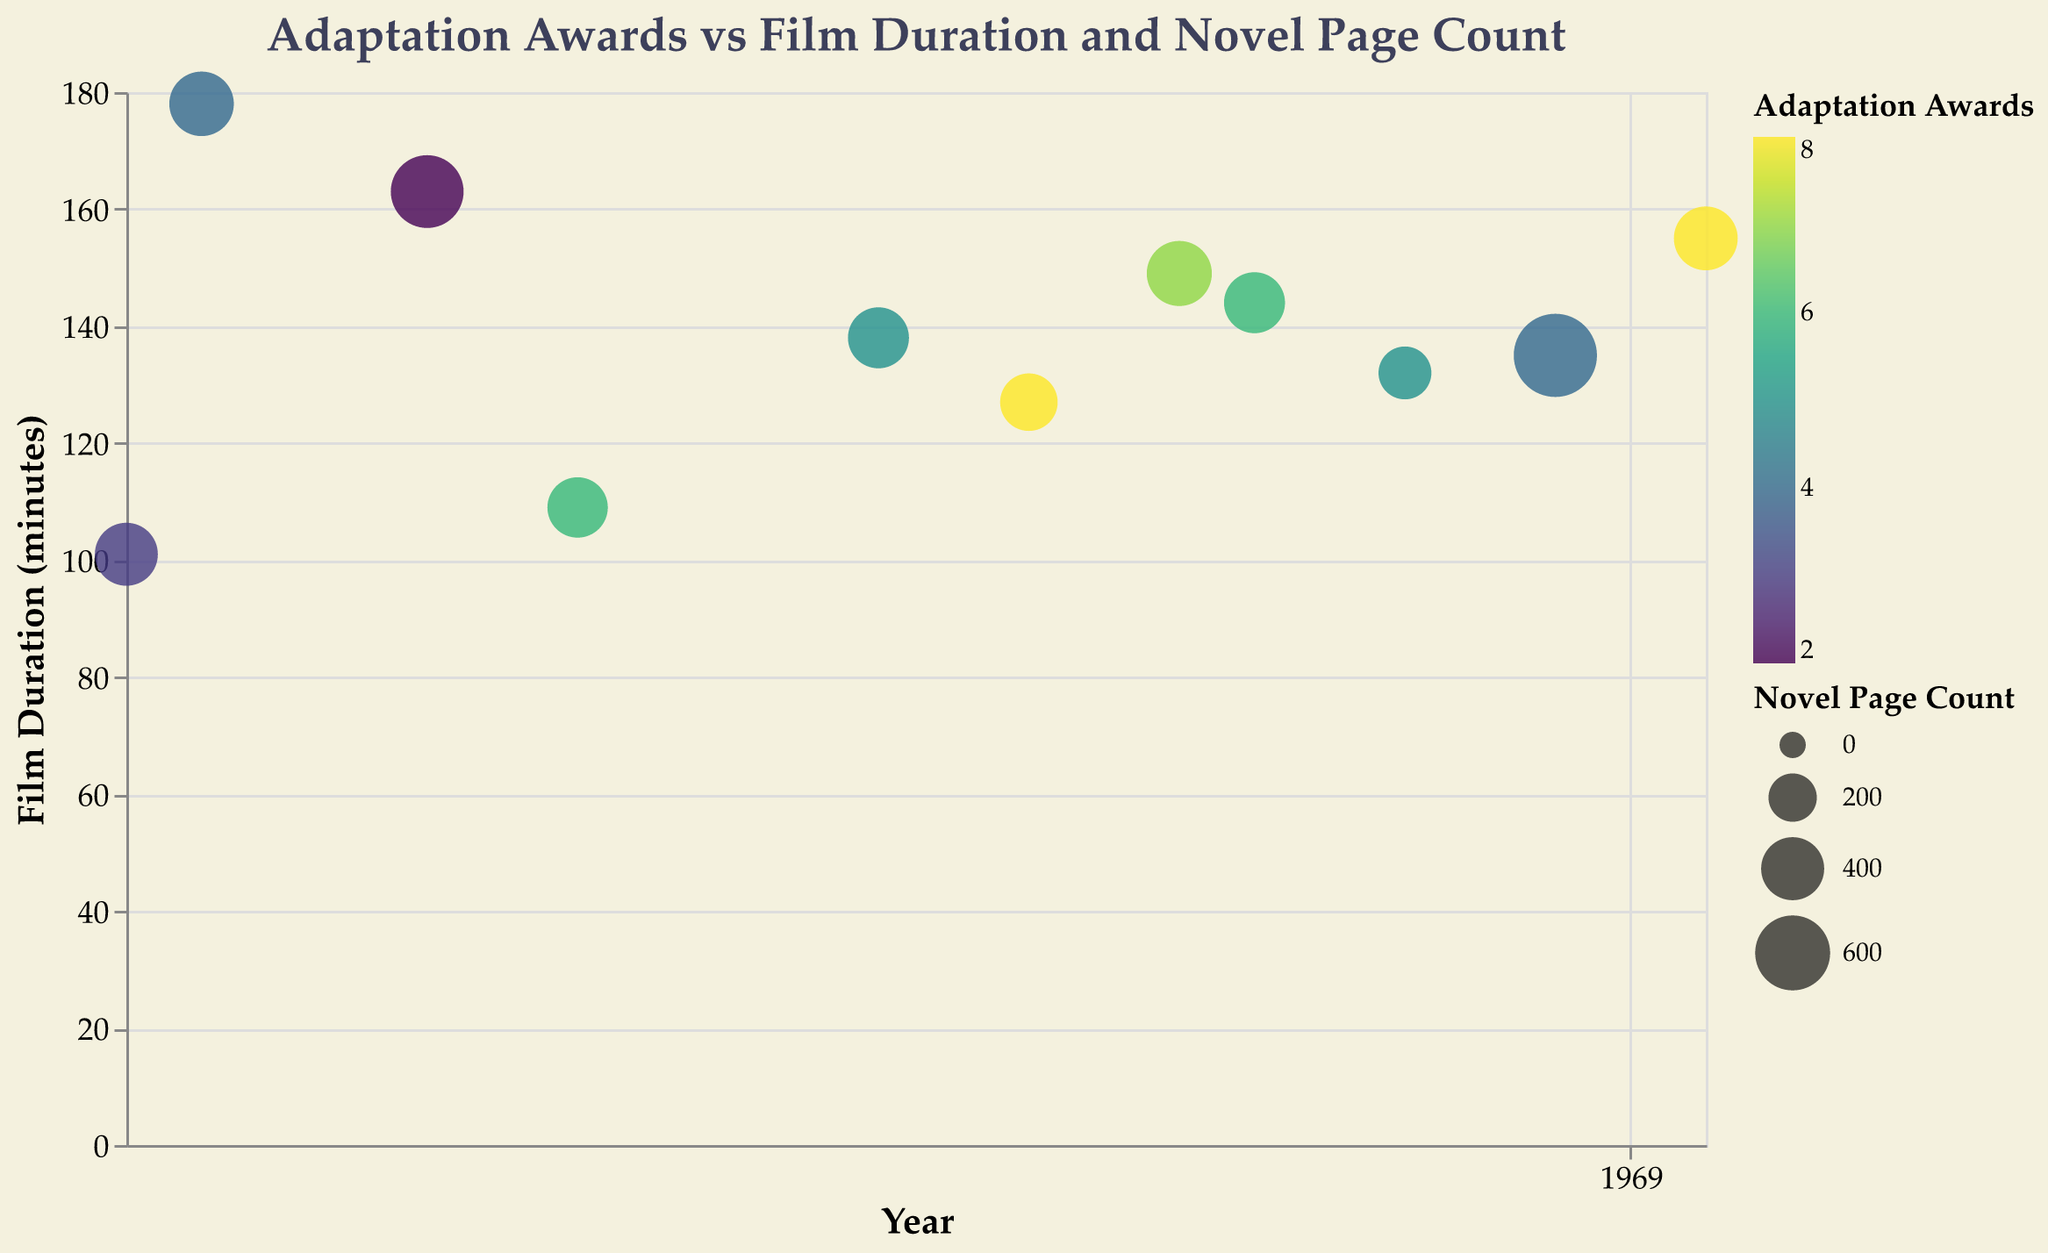What's the title of the figure? The title of the figure appears at the top of the chart in larger font. It is a descriptive title summarizing the visualized data.
Answer: Adaptation Awards vs Film Duration and Novel Page Count Which film has the highest number of adaptation awards? To find the answer, look for the bubble with the highest color density. The tooltip will show the exact title when hovered over. "Life of Pi" and "Dune" are the two options here, both have 8 awards.
Answer: Life of Pi, Dune What is the novel page count for "Little Women"? Locate the bubble corresponding to "Little Women" using the tooltip. The size of the bubble reveals the novel page count.
Answer: 759 Which year has the film with the shortest duration, and what is that duration? Identify the smallest Y-value (lowest position on the vertical axis), then use the tooltip to find the corresponding year and duration. "American Psycho" in 2000 appears to have the shortest duration.
Answer: 2000, 101 minutes Which film has both the longest film duration and its corresponding awards? Look for the bubble positioned highest on the vertical axis and use the tooltip for exact data. "Lord of the Rings: The Fellowship of the Ring" has the longest duration of 178 minutes with 4 awards.
Answer: Lord of the Rings: The Fellowship of the Ring, 4 awards How does "Gone Girl" compare to "The Martian" in terms of adaptation awards? Use the tooltip to look at the color values for "Gone Girl" and "The Martian". "Gone Girl" has 7 awards, while "The Martian" has 6 awards. Therefore, "Gone Girl" has one more award.
Answer: Gone Girl has 1 more award Which director has directed films with a total of 10 adaptation awards? Sum awards for each director and locate the director with a cumulative total of 10. David Fincher's "Gone Girl" (7) and David Frankel's "The Devil Wears Prada" (6). Both exceed 10. Looking carefully, no one hits exactly 10.
Answer: No director with exactly 10 awards What is the average film duration for films with 8 adaptation awards? Identify the films with 8 adaptation awards: "Life of Pi" (127 min) and "Dune" (155 min). Calculate the average: (127 + 155) / 2 = 141 minutes.
Answer: 141 minutes Which year has the highest number of adaptation awards cumulatively for all films released that year? Manually sum adaptation awards for each year, e.g., "2001: 4," "2004: 2," etc. Identify 2021 with "Dune" having the highest single count of 8. Corroborating multiple years, no accumulative year exceeds any single high-count standalone year. Ensure correct.
Answer: 2021 with Dune 